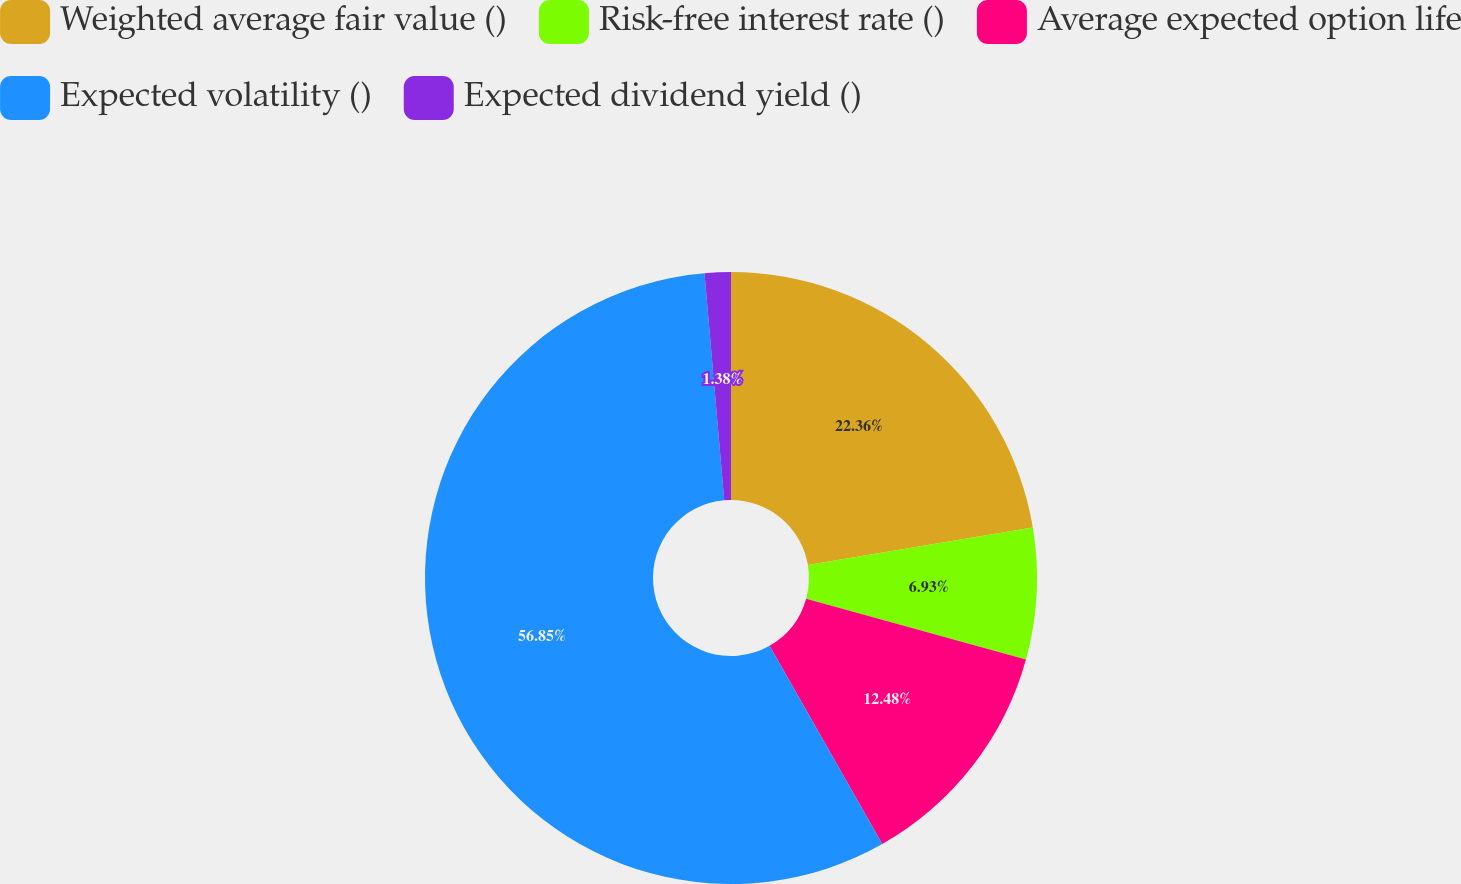Convert chart. <chart><loc_0><loc_0><loc_500><loc_500><pie_chart><fcel>Weighted average fair value ()<fcel>Risk-free interest rate ()<fcel>Average expected option life<fcel>Expected volatility ()<fcel>Expected dividend yield ()<nl><fcel>22.36%<fcel>6.93%<fcel>12.48%<fcel>56.85%<fcel>1.38%<nl></chart> 